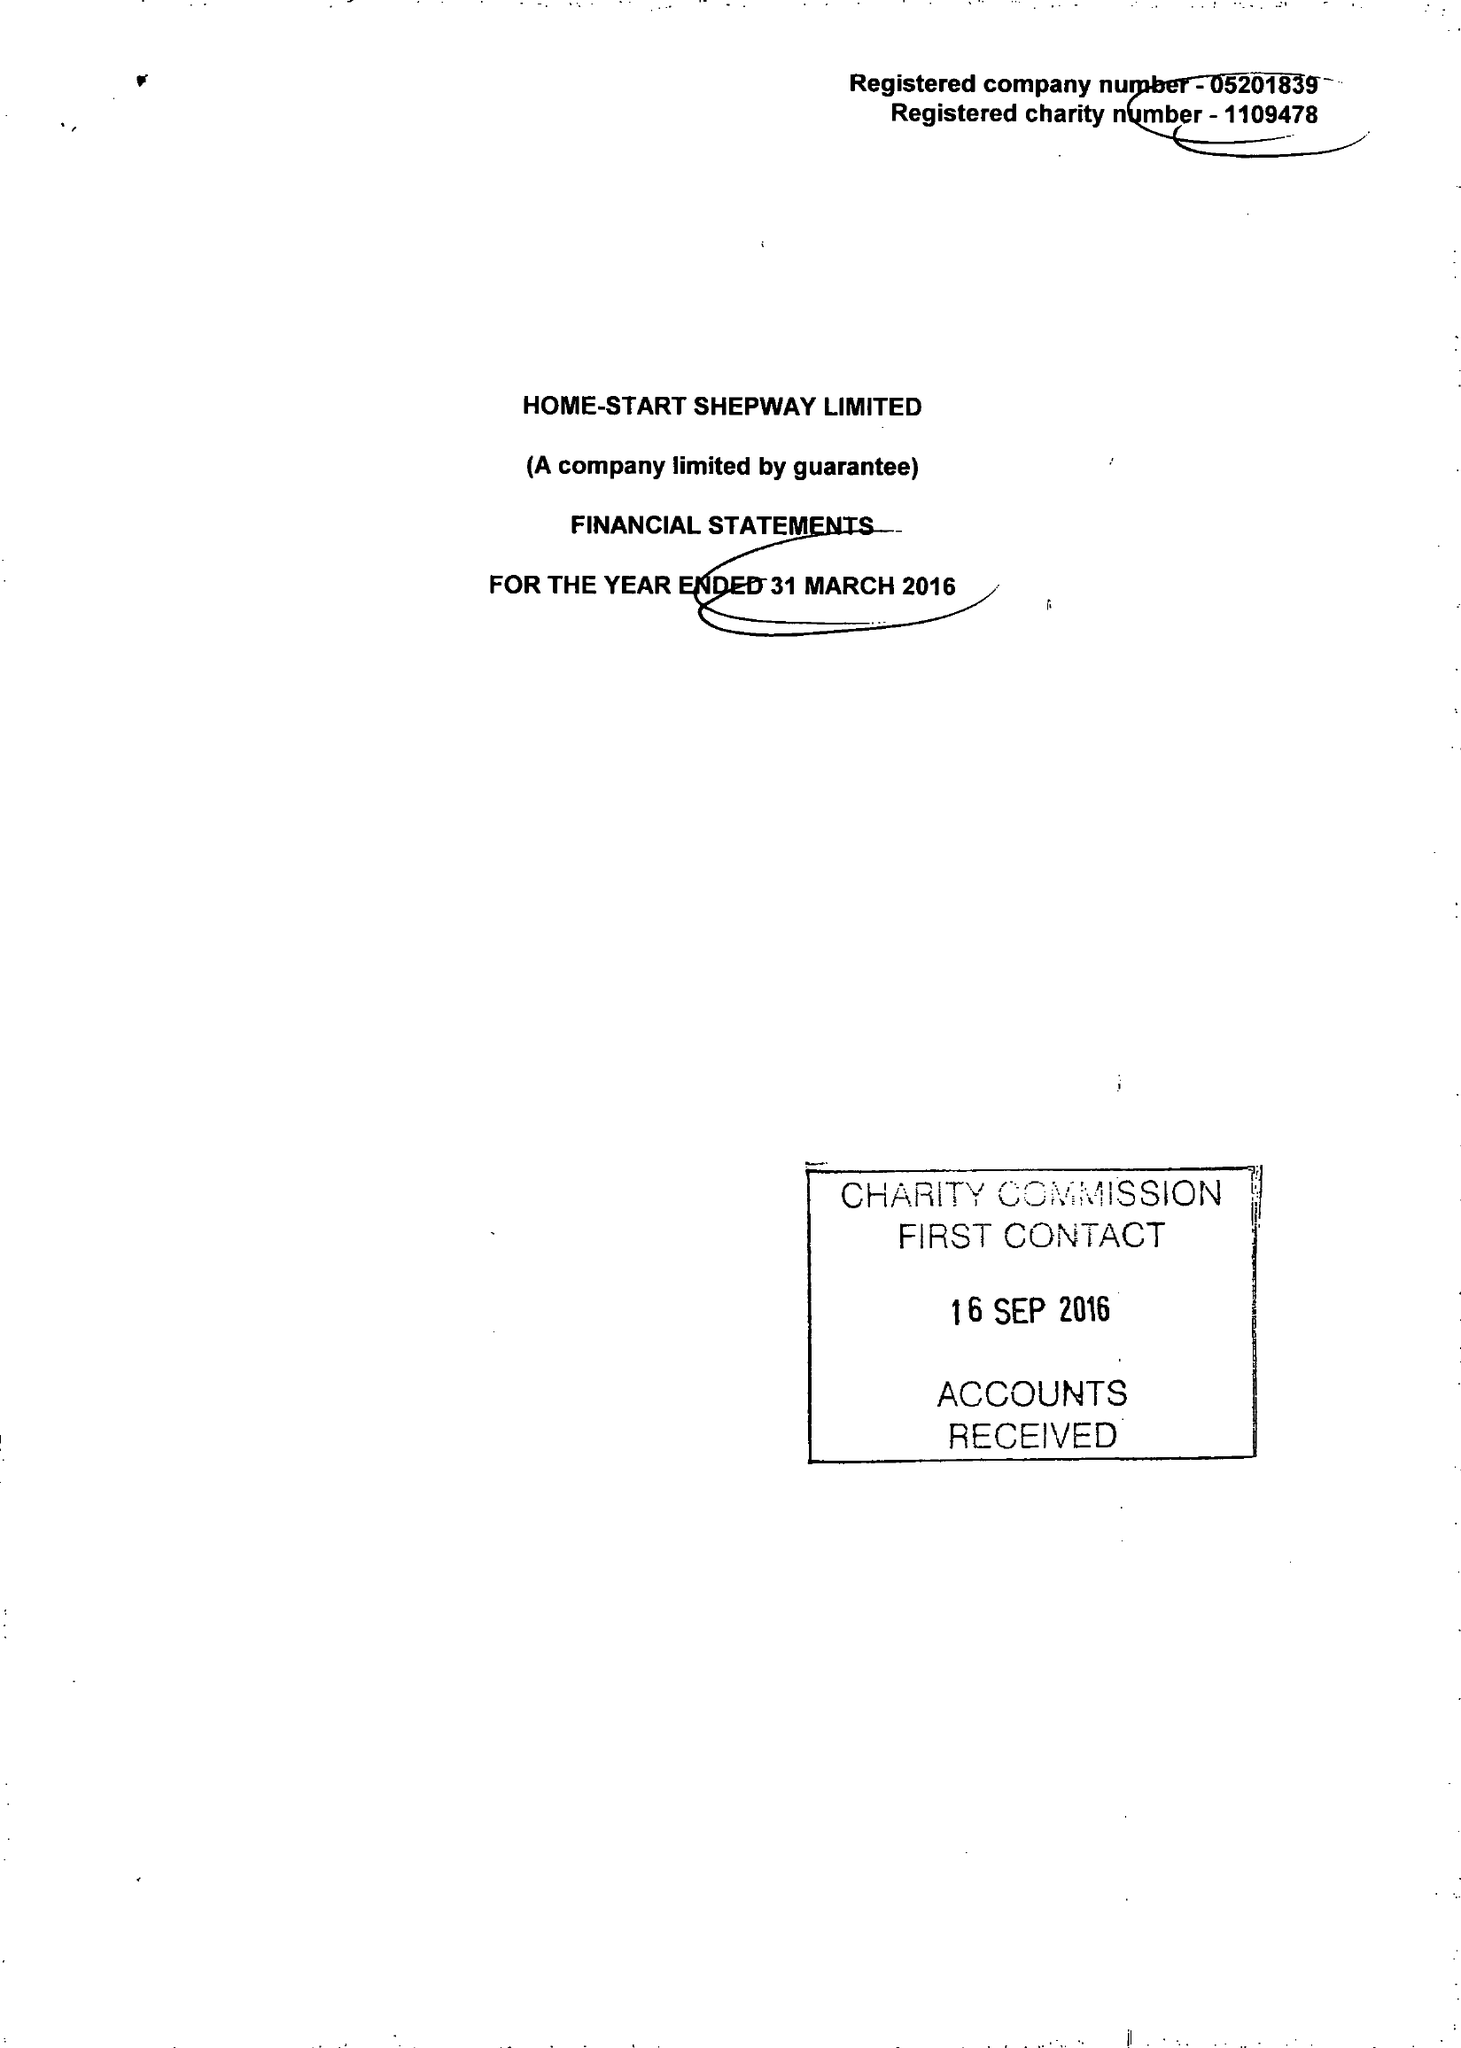What is the value for the report_date?
Answer the question using a single word or phrase. 2016-03-31 